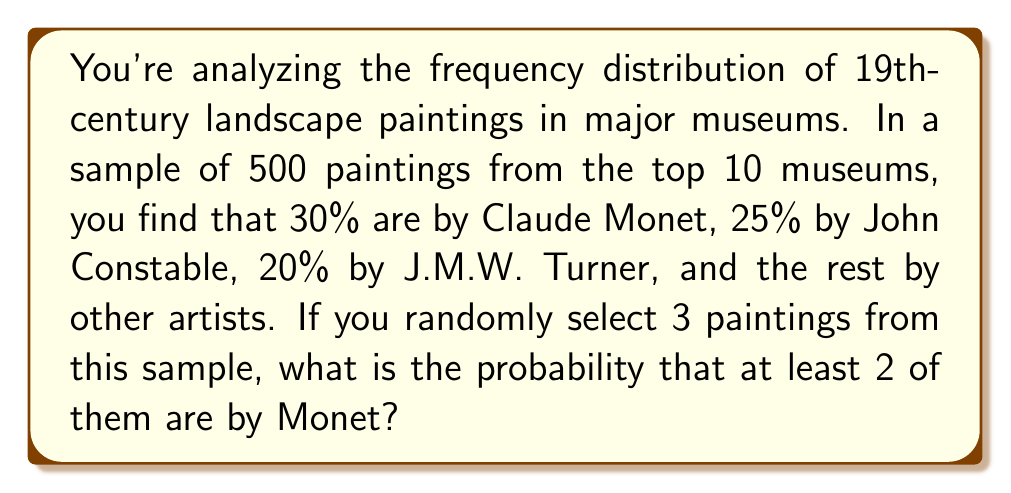Could you help me with this problem? Let's approach this step-by-step:

1) First, we need to calculate the probability of selecting a Monet painting:
   $P(\text{Monet}) = 0.30$ or $30\%$

2) The probability of selecting a non-Monet painting is:
   $P(\text{Not Monet}) = 1 - 0.30 = 0.70$ or $70\%$

3) Now, we need to consider the probability of at least 2 out of 3 paintings being by Monet. This can happen in two ways:
   a) All 3 paintings are by Monet
   b) Exactly 2 out of 3 paintings are by Monet

4) Let's calculate these probabilities:
   a) $P(\text{3 Monets}) = 0.30 \times 0.30 \times 0.30 = 0.027$
   b) $P(\text{2 Monets, 1 Not}) = \binom{3}{2} \times 0.30^2 \times 0.70 = 3 \times 0.30^2 \times 0.70 = 0.189$

5) The probability of at least 2 Monets is the sum of these probabilities:
   $P(\text{at least 2 Monets}) = P(\text{3 Monets}) + P(\text{2 Monets, 1 Not})$
   $= 0.027 + 0.189 = 0.216$

Therefore, the probability of selecting at least 2 Monet paintings out of 3 random selections is 0.216 or 21.6%.
Answer: 0.216 